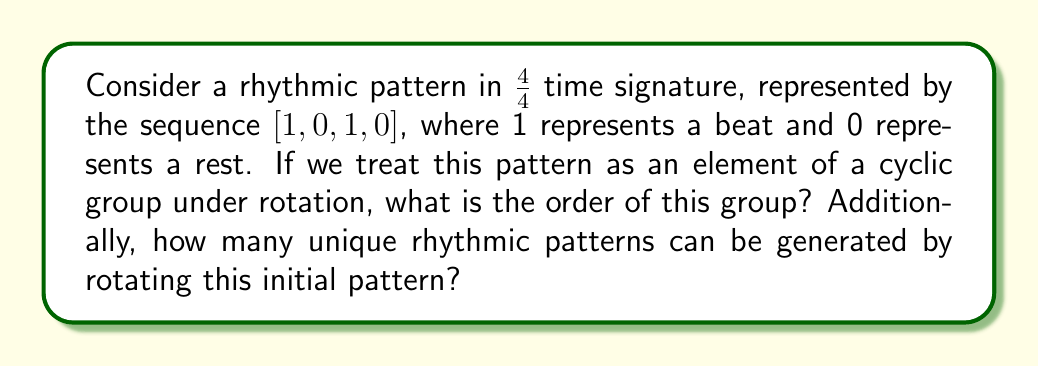Teach me how to tackle this problem. To solve this problem, we need to understand cyclic groups and how they relate to rhythmic patterns:

1) First, let's consider the given pattern [1, 0, 1, 0] in a 4/4 time signature. This represents a rhythm where there's a beat on the 1st and 3rd quarter notes, and rests on the 2nd and 4th.

2) In group theory, a cyclic group is a group that can be generated by a single element, called the generator. In our case, the generator is the initial pattern, and the group operation is rotation.

3) To find the order of the group, we need to determine how many rotations it takes to get back to the original pattern. Let's rotate the pattern:

   Original: [1, 0, 1, 0]
   Rotate 1: [0, 1, 0, 1]
   Rotate 2: [1, 0, 1, 0]

4) We see that after two rotations, we're back to the original pattern. This means the order of the group is 2.

5) The number of unique patterns generated by rotation will be equal to the order of the group. In this case, there are 2 unique patterns:
   [1, 0, 1, 0] and [0, 1, 0, 1]

6) Mathematically, we can represent this cyclic group as:

   $$C_2 = \{\text{[1, 0, 1, 0], [0, 1, 0, 1]}\}$$

   Where $C_2$ denotes a cyclic group of order 2.

This concept is relevant to music composition as it demonstrates how a simple rhythmic pattern can generate different variations through rotation, potentially inspiring new rhythmic ideas within the same time signature.
Answer: The order of the cyclic group is 2, and there are 2 unique rhythmic patterns that can be generated by rotating the initial pattern. 